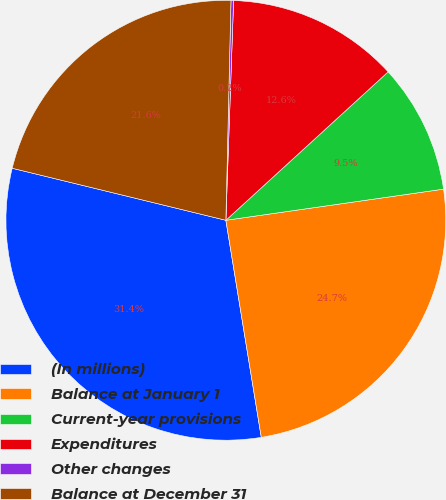Convert chart. <chart><loc_0><loc_0><loc_500><loc_500><pie_chart><fcel>(In millions)<fcel>Balance at January 1<fcel>Current-year provisions<fcel>Expenditures<fcel>Other changes<fcel>Balance at December 31<nl><fcel>31.38%<fcel>24.69%<fcel>9.53%<fcel>12.65%<fcel>0.19%<fcel>21.57%<nl></chart> 